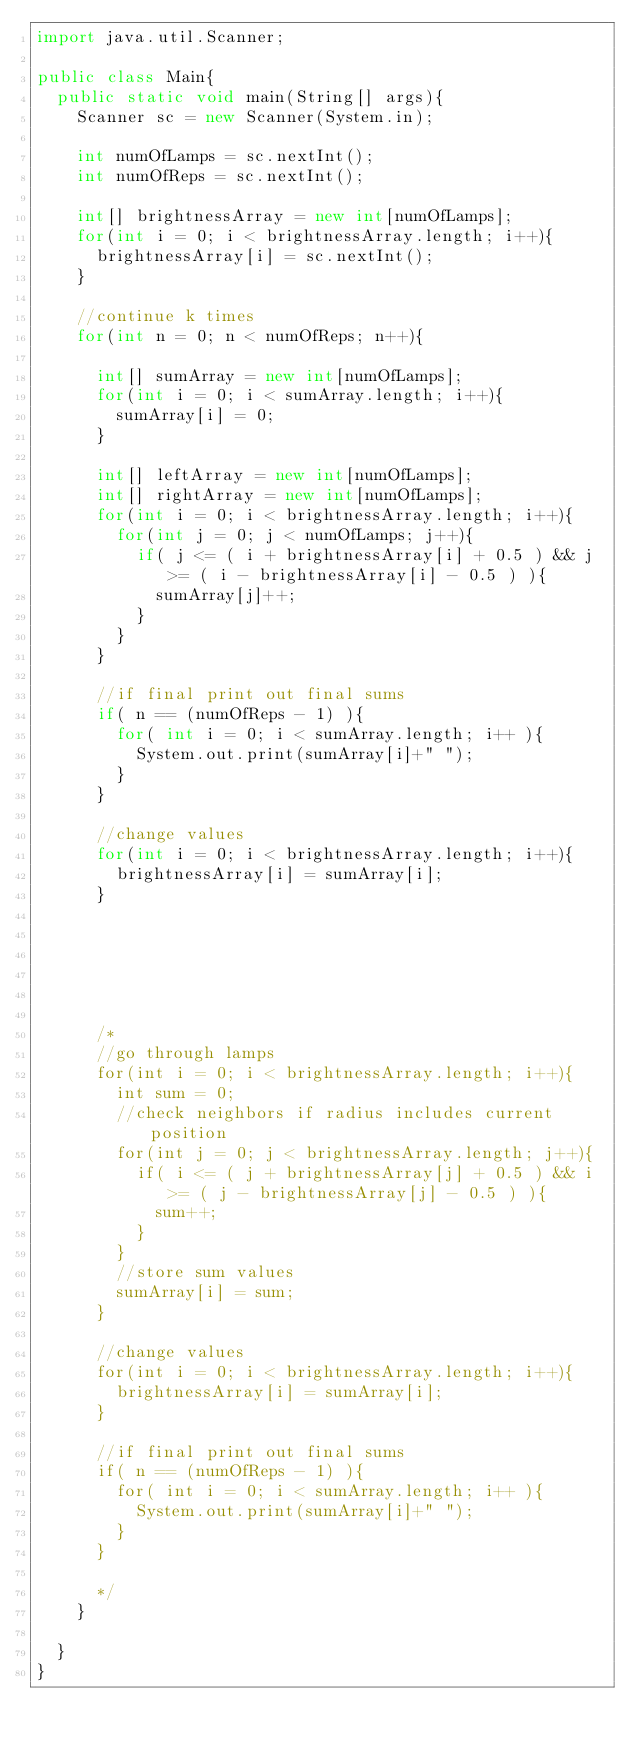<code> <loc_0><loc_0><loc_500><loc_500><_Java_>import java.util.Scanner;

public class Main{
  public static void main(String[] args){
    Scanner sc = new Scanner(System.in);

    int numOfLamps = sc.nextInt();
    int numOfReps = sc.nextInt();

    int[] brightnessArray = new int[numOfLamps];
    for(int i = 0; i < brightnessArray.length; i++){
      brightnessArray[i] = sc.nextInt();
    }

    //continue k times
    for(int n = 0; n < numOfReps; n++){

      int[] sumArray = new int[numOfLamps];
      for(int i = 0; i < sumArray.length; i++){
        sumArray[i] = 0;
      }

      int[] leftArray = new int[numOfLamps];
      int[] rightArray = new int[numOfLamps];
      for(int i = 0; i < brightnessArray.length; i++){
        for(int j = 0; j < numOfLamps; j++){
          if( j <= ( i + brightnessArray[i] + 0.5 ) && j >= ( i - brightnessArray[i] - 0.5 ) ){
            sumArray[j]++;
          }
        }
      }

      //if final print out final sums
      if( n == (numOfReps - 1) ){
        for( int i = 0; i < sumArray.length; i++ ){
          System.out.print(sumArray[i]+" ");
        }
      }

      //change values
      for(int i = 0; i < brightnessArray.length; i++){
        brightnessArray[i] = sumArray[i];
      }






      /*
      //go through lamps
      for(int i = 0; i < brightnessArray.length; i++){
        int sum = 0;
        //check neighbors if radius includes current position
        for(int j = 0; j < brightnessArray.length; j++){
          if( i <= ( j + brightnessArray[j] + 0.5 ) && i >= ( j - brightnessArray[j] - 0.5 ) ){
            sum++;
          }
        }
        //store sum values
        sumArray[i] = sum;
      }

      //change values
      for(int i = 0; i < brightnessArray.length; i++){
        brightnessArray[i] = sumArray[i];
      }

      //if final print out final sums
      if( n == (numOfReps - 1) ){
        for( int i = 0; i < sumArray.length; i++ ){
          System.out.print(sumArray[i]+" ");
        }
      }

      */
    }

  }
}
</code> 